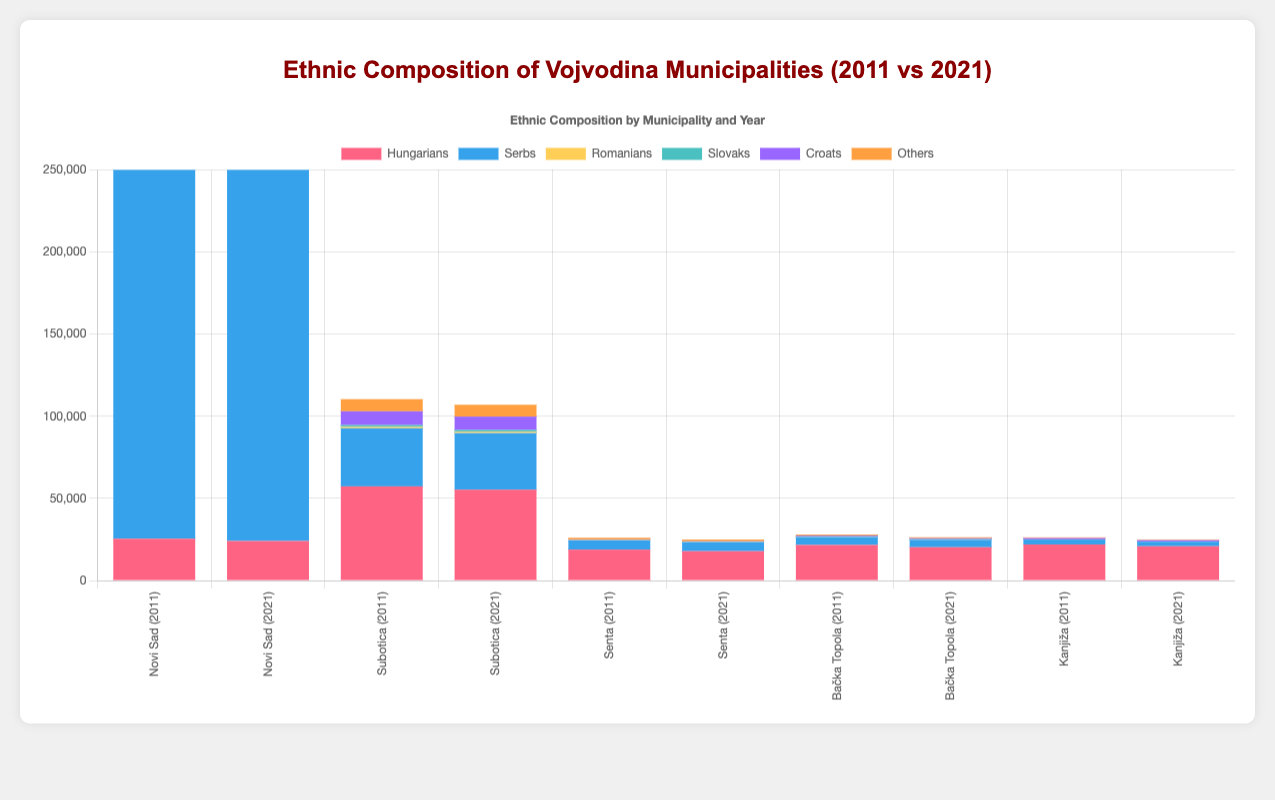Which municipality had the largest Hungarian population in 2021? By examining the bars for Hungarians in 2021 across all municipalities, Subotica has the largest height. This indicates that it had the largest Hungarian population in 2021.
Answer: Subotica How did the Serb population in Novi Sad change from 2011 to 2021? Check the heights of the bars representing the Serb population in Novi Sad for 2011 and 2021. The height increased from 232500 in 2011 to 234200 in 2021, indicating a slight increase.
Answer: Slight increase In which municipality did the Romanian population remain the most stable between 2011 and 2021? Compare the heights of the Romanian population bars for each municipality in 2011 and 2021. Kanjiža shows the most stability, with only a slight change from 53 to 51.
Answer: Kanjiža Which ethnic group had the sharpest decline in Subotica between 2011 and 2021? Analyze the dataset for each ethnic group in Subotica. The Hungarian population dropped from 57340 in 2011 to 55320 in 2021, recording a decline of 2020, which is the sharpest among the listed groups.
Answer: Hungarians What is the total population of Croats in all municipalities combined for the year 2021? Sum the values of the Croat population across the five municipalities in 2021. The total is (Novi Sad: 8560) + (Subotica: 8120) + (Senta: 240) + (Bačka Topola: 530) + (Kanjiža: 780) = 18230.
Answer: 18230 By how much did the "Others" category population decrease in Bačka Topola from 2011 to 2021? Compare the "Others" category population in Bačka Topola for 2011 (600) and 2021 (580). The decrease is 600 - 580 = 20.
Answer: 20 Which municipality had the lowest population of Slovaks in 2021? Look at the heights of the bars representing the Slovak population in each municipality for 2021. Kanjiža had the lowest population of Slovaks, with only 65.
Answer: Kanjiža What was the average population of Hungarians across all municipalities in 2011? Sum the Hungarian population across all municipalities in 2011 and divide by the number of municipalities: (Novi Sad: 25480) + (Subotica: 57340) + (Senta: 18850) + (Bačka Topola: 21690) + (Kanjiža: 21980) = 145340. The average is 145340 / 5 = 29068.
Answer: 29068 